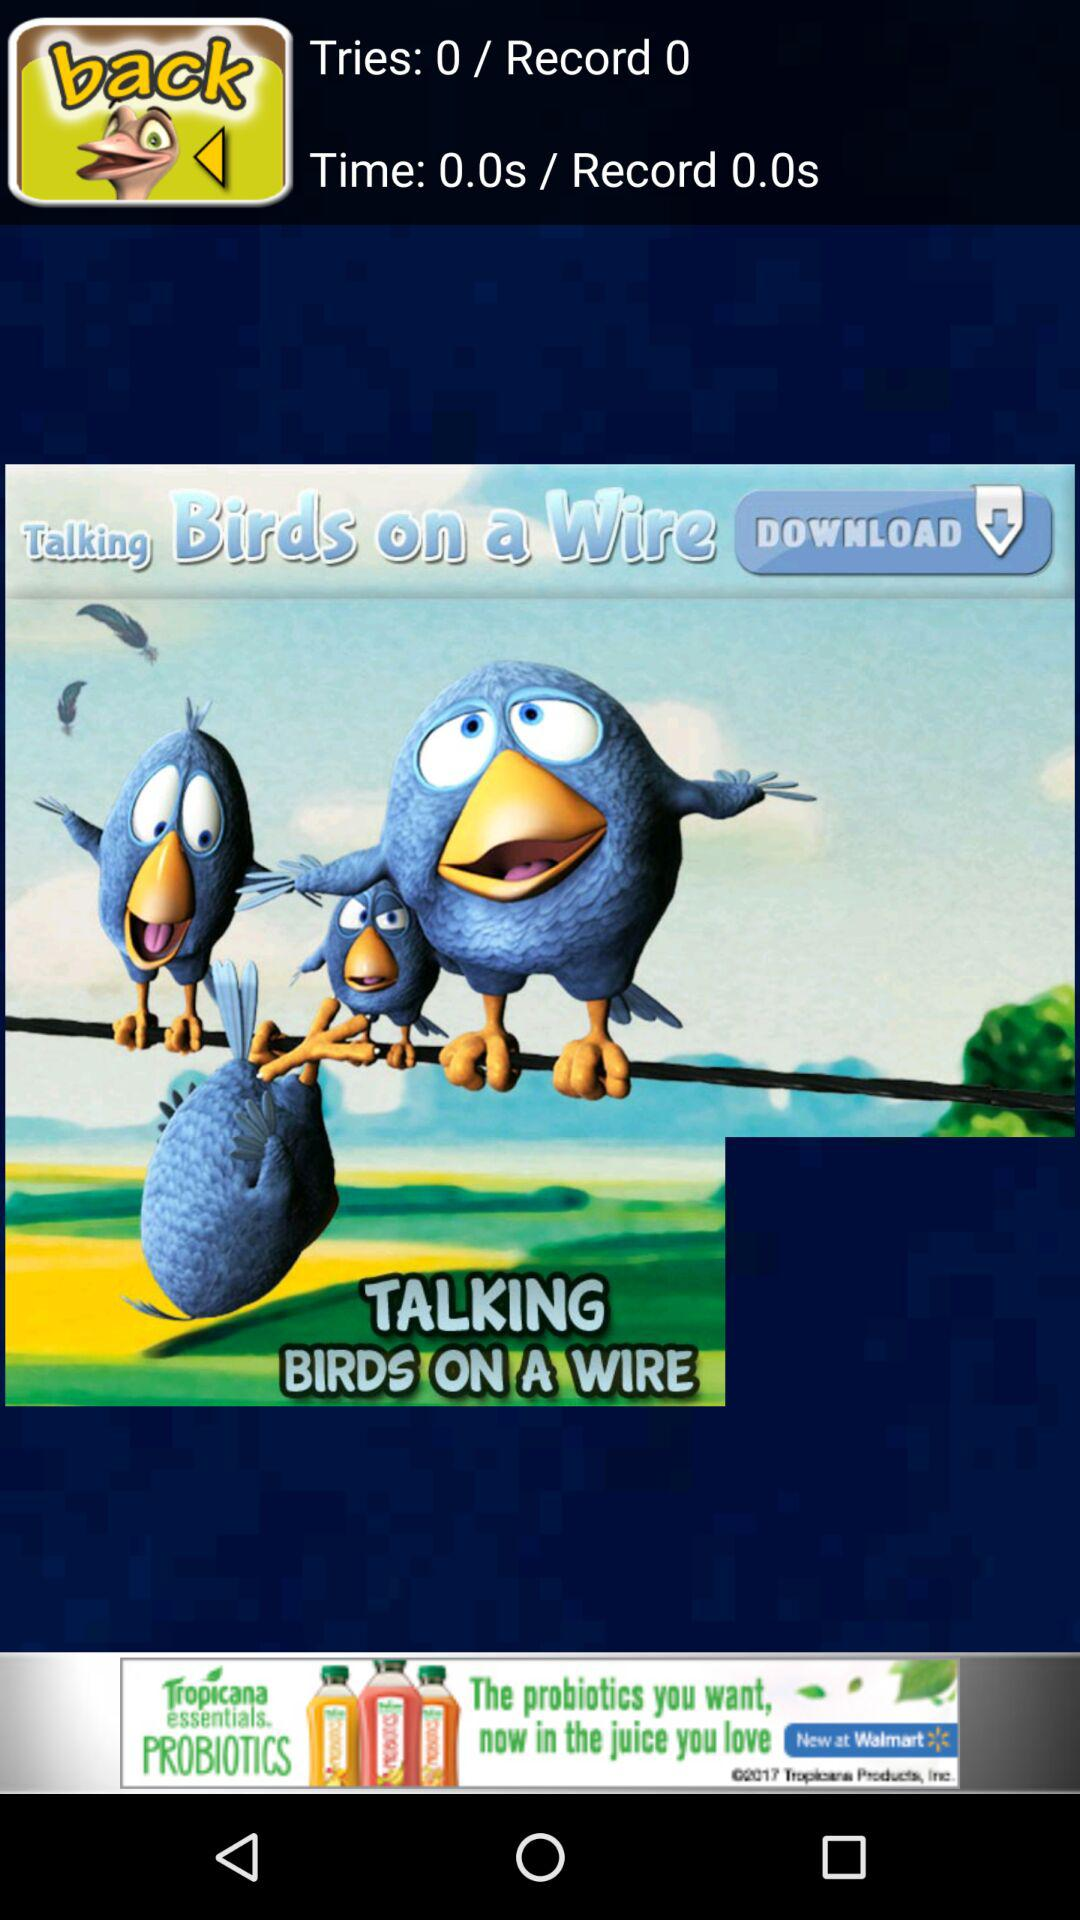What is the time? The time is 0.0 seconds. 